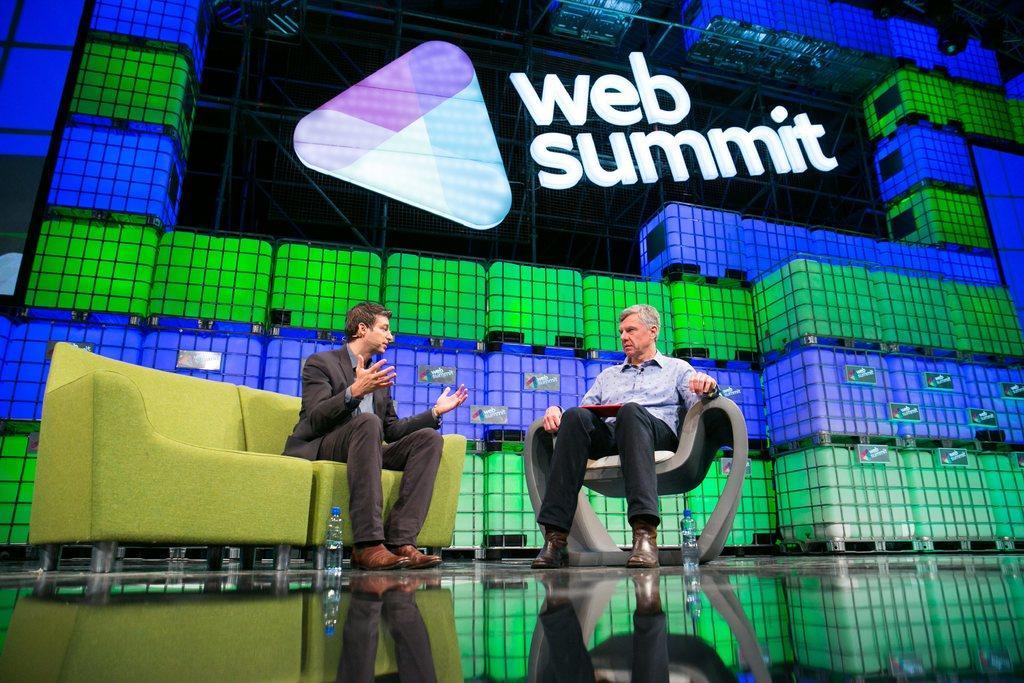Describe this image in one or two sentences. In the picture there are two persons sitting and talking, behind them there is a board with the text. 